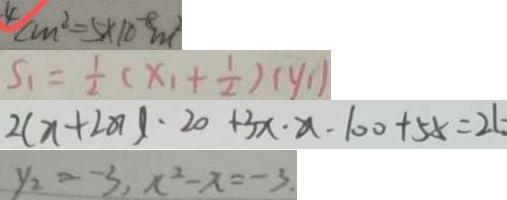<formula> <loc_0><loc_0><loc_500><loc_500>4 c m ^ { 2 } = 5 \times 1 0 ^ { - 8 } m ^ { 2 } 
 S _ { 1 } = \frac { 1 } { 2 } ( x _ { 1 } + \frac { 1 } { 2 } ) ( y _ { 1 } ) 
 2 ( x + 2 0 ) \cdot 2 0 + 3 x \cdot x - 1 0 0 + 5 x = 2 6 
 y _ { 2 } = - 3 , x ^ { 2 } - x = - 3</formula> 